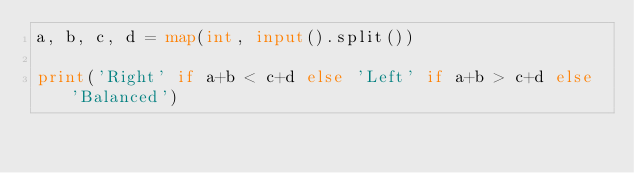<code> <loc_0><loc_0><loc_500><loc_500><_Python_>a, b, c, d = map(int, input().split())

print('Right' if a+b < c+d else 'Left' if a+b > c+d else 'Balanced')</code> 